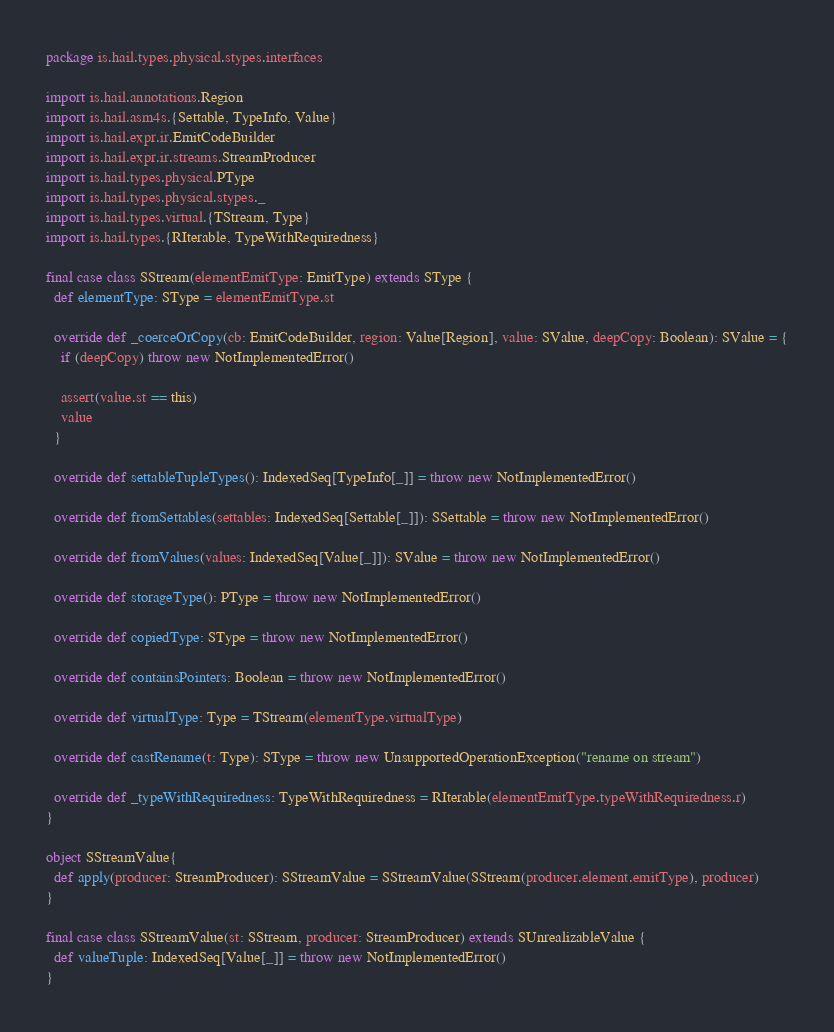<code> <loc_0><loc_0><loc_500><loc_500><_Scala_>package is.hail.types.physical.stypes.interfaces

import is.hail.annotations.Region
import is.hail.asm4s.{Settable, TypeInfo, Value}
import is.hail.expr.ir.EmitCodeBuilder
import is.hail.expr.ir.streams.StreamProducer
import is.hail.types.physical.PType
import is.hail.types.physical.stypes._
import is.hail.types.virtual.{TStream, Type}
import is.hail.types.{RIterable, TypeWithRequiredness}

final case class SStream(elementEmitType: EmitType) extends SType {
  def elementType: SType = elementEmitType.st

  override def _coerceOrCopy(cb: EmitCodeBuilder, region: Value[Region], value: SValue, deepCopy: Boolean): SValue = {
    if (deepCopy) throw new NotImplementedError()

    assert(value.st == this)
    value
  }

  override def settableTupleTypes(): IndexedSeq[TypeInfo[_]] = throw new NotImplementedError()

  override def fromSettables(settables: IndexedSeq[Settable[_]]): SSettable = throw new NotImplementedError()

  override def fromValues(values: IndexedSeq[Value[_]]): SValue = throw new NotImplementedError()

  override def storageType(): PType = throw new NotImplementedError()

  override def copiedType: SType = throw new NotImplementedError()

  override def containsPointers: Boolean = throw new NotImplementedError()

  override def virtualType: Type = TStream(elementType.virtualType)

  override def castRename(t: Type): SType = throw new UnsupportedOperationException("rename on stream")

  override def _typeWithRequiredness: TypeWithRequiredness = RIterable(elementEmitType.typeWithRequiredness.r)
}

object SStreamValue{
  def apply(producer: StreamProducer): SStreamValue = SStreamValue(SStream(producer.element.emitType), producer)
}

final case class SStreamValue(st: SStream, producer: StreamProducer) extends SUnrealizableValue {
  def valueTuple: IndexedSeq[Value[_]] = throw new NotImplementedError()
}
</code> 